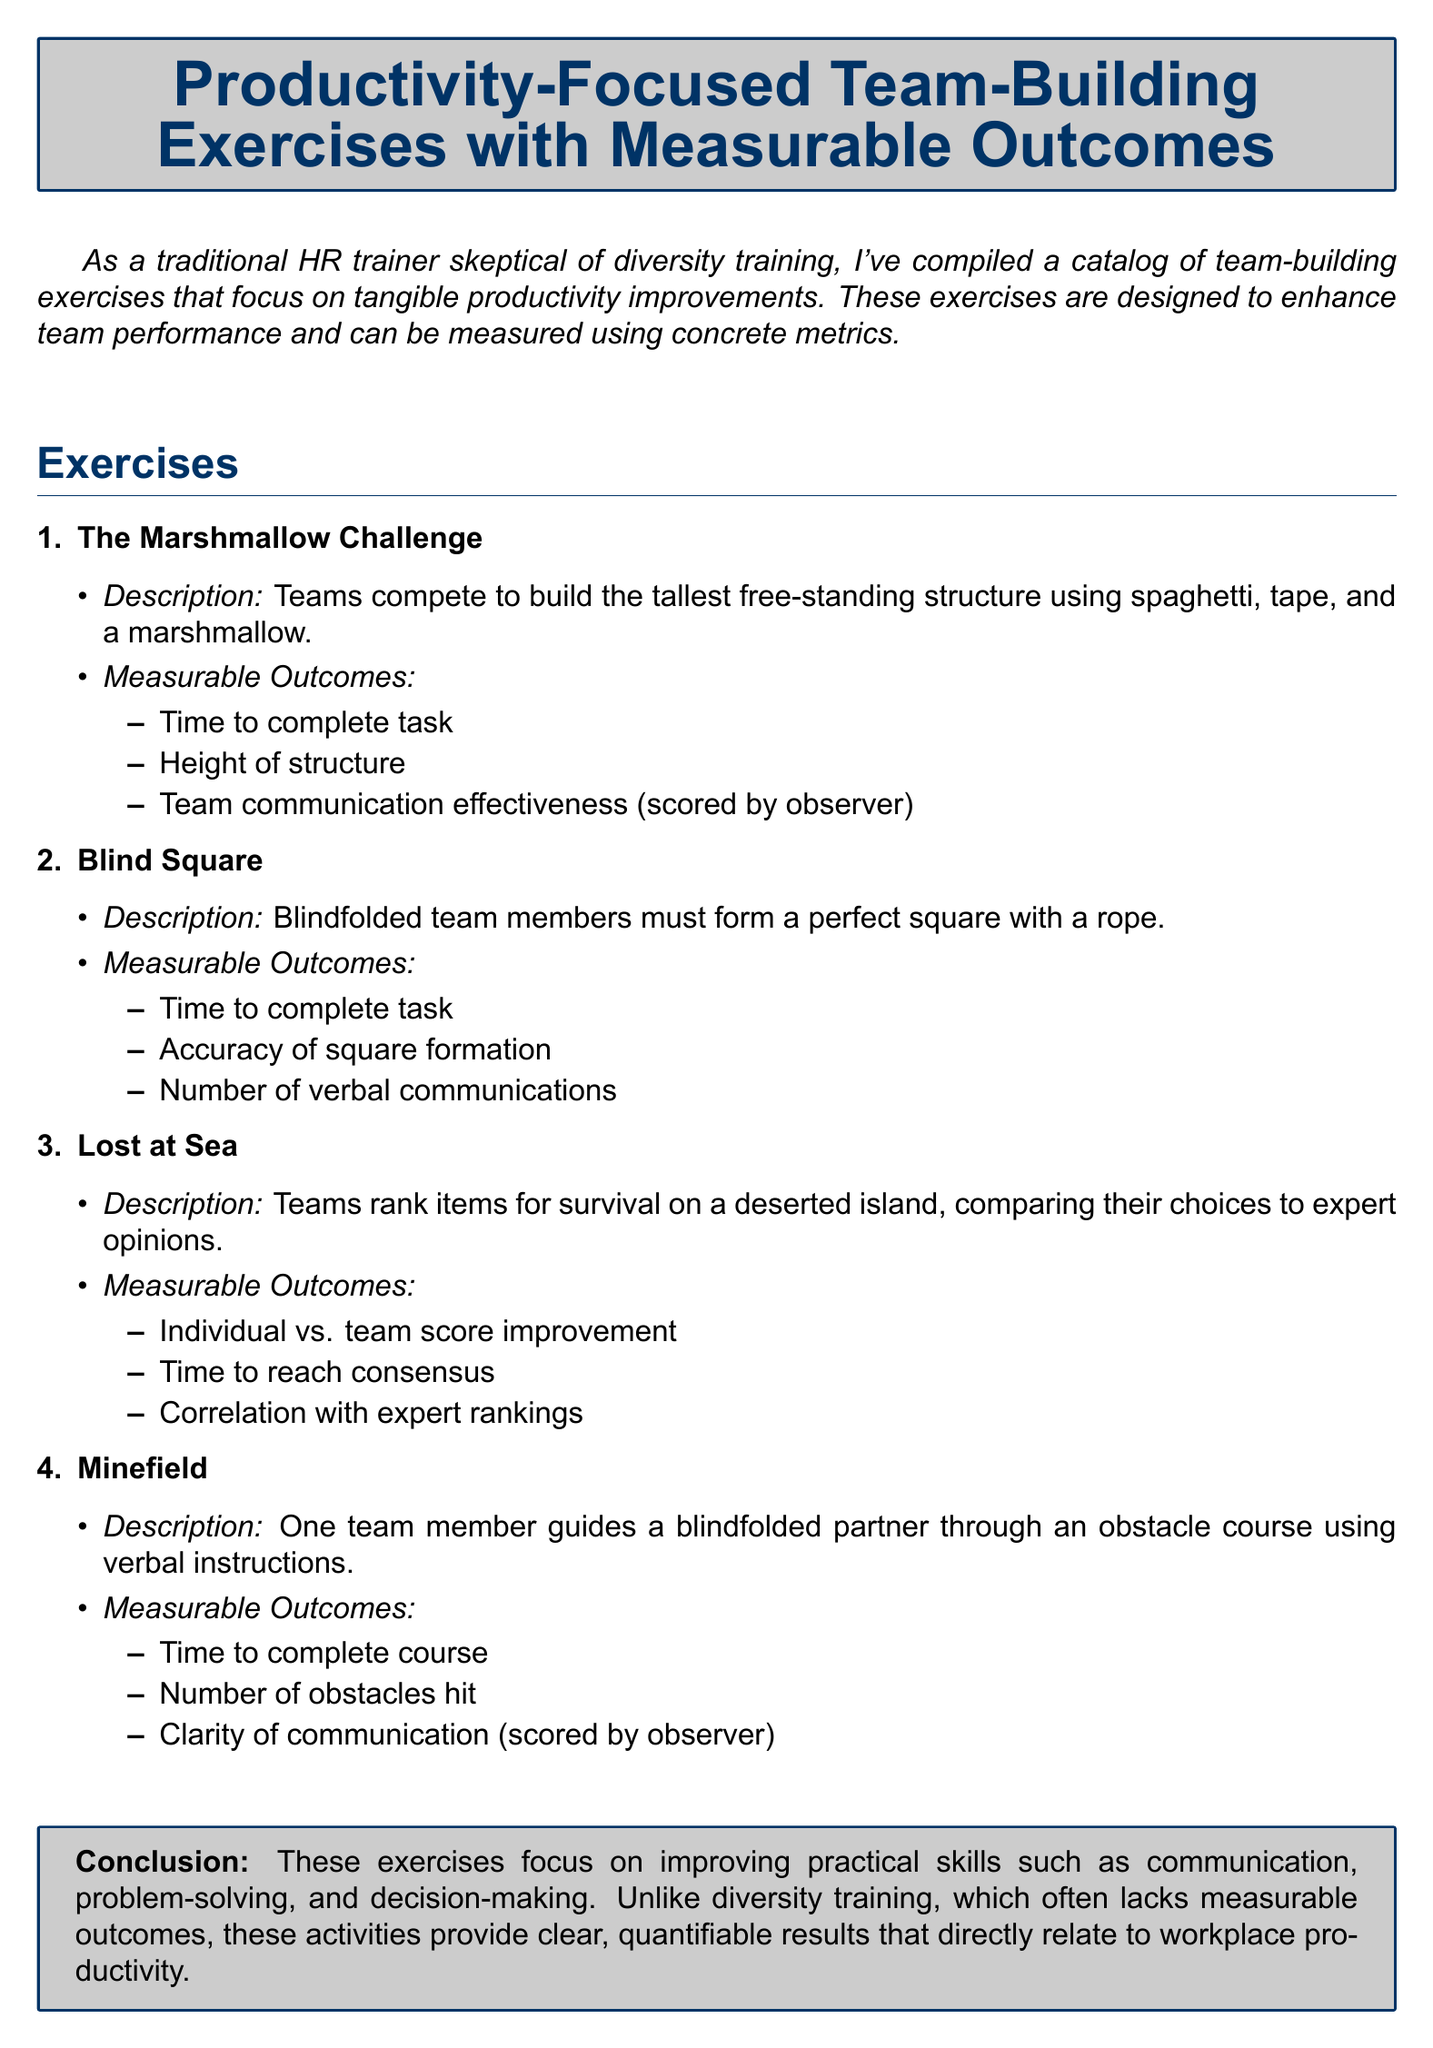What is the first exercise listed? The first exercise is explicitly mentioned at the beginning of the exercise section as "The Marshmallow Challenge."
Answer: The Marshmallow Challenge How many measurable outcomes are listed for the "Blind Square" exercise? The document lists three measurable outcomes for the "Blind Square" exercise.
Answer: 3 What is the main focus of the team-building exercises? The document states that the focus of the exercises is on enhancing team performance and measurable productivity improvements.
Answer: Enhancing team performance What is the time metric used in the "Lost at Sea" exercise? The time metric mentioned is "Time to reach consensus."
Answer: Time to reach consensus What is measured for the "Minefield" exercise regarding communication? The clarity of communication is scored by an observer as one of the measurable outcomes.
Answer: Clarity of communication Which exercise requires team members to rank items for survival? The exercise that involves ranking items for survival is explicitly named "Lost at Sea."
Answer: Lost at Sea How does the document perceive diversity training compared to these exercises? The document suggests that diversity training often lacks measurable outcomes, unlike the listed exercises.
Answer: Lacks measurable outcomes What type of skills do these exercises aim to improve? The exercises focus on improving practical skills such as communication and problem-solving.
Answer: Practical skills 